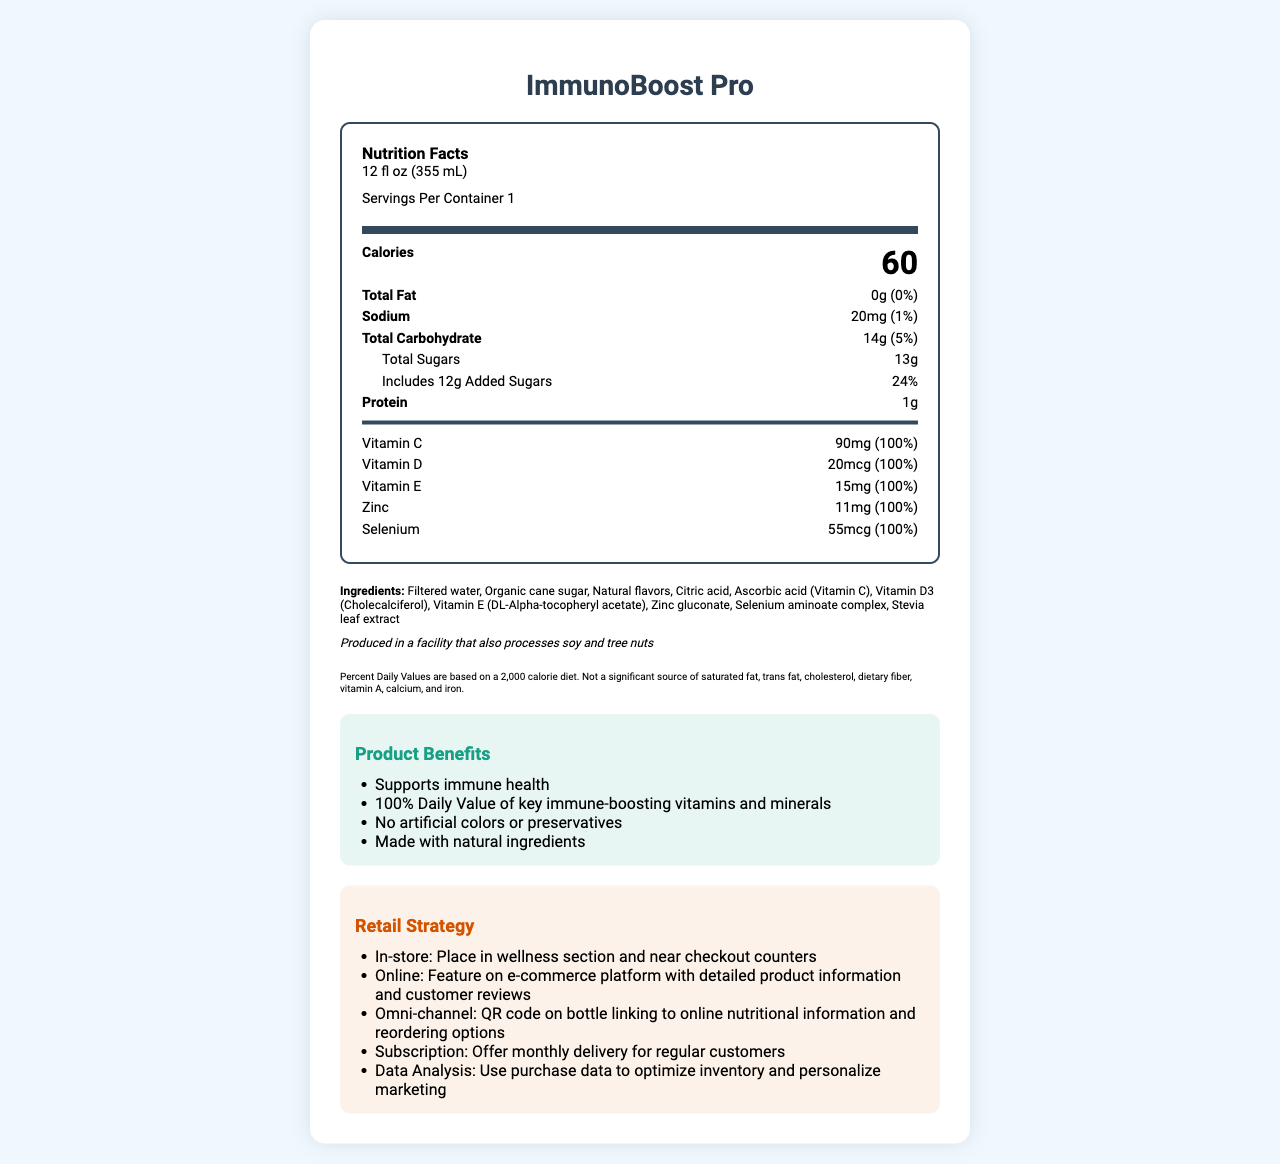what is the serving size for ImmunoBoost Pro? The serving size is directly stated under the "Nutrition Facts" section of the document.
Answer: 12 fl oz (355 mL) how many calories are there per serving? The calories per serving are listed prominently within the "Nutrition Facts" section.
Answer: 60 what amount of added sugars does ImmunoBoost Pro contain? The added sugars are specified under the "Total Sugars" section, whereby it states 12g of added sugars.
Answer: 12g which vitamins and minerals are 100% of the daily value (DV) in ImmunoBoost Pro? The daily value of 100% is given for Vitamin C (90mg), Vitamin D (20mcg), Vitamin E (15mg), Zinc (11mg), and Selenium (55mcg).
Answer: Vitamin C, Vitamin D, Vitamin E, Zinc, Selenium what are the main ingredients of ImmunoBoost Pro? The ingredients are listed under the "Ingredients" section of the document.
Answer: Filtered water, Organic cane sugar, Natural flavors, Citric acid, Ascorbic acid (Vitamin C), Vitamin D3 (Cholecalciferol), Vitamin E (DL-Alpha-tocopheryl acetate), Zinc gluconate, Selenium aminoate complex, Stevia leaf extract how much protein is in one serving of ImmunoBoost Pro? The protein content is listed at 1g per serving under the "Nutrition Facts".
Answer: 1g what is the sodium content per serving? The sodium content per serving is found under the "Nutrition Facts" and is listed as 20mg.
Answer: 20mg ImmunoBoost Pro is produced in a facility that processes which allergens? A. Dairy and peanuts B. Gluten and shellfish C. Soy and tree nuts D. Eggs and fish The allergen information specifies that the product is produced in a facility that processes soy and tree nuts.
Answer: C how is ImmunoBoost Pro marketed to support immune health? A. High protein content B. Low calorie C. 100% Daily Value of key immune-boosting vitamins and minerals D. Zero carbohydrates The marketing claims specify that the product has "100% Daily Value of key immune-boosting vitamins and minerals".
Answer: C is there any iron in ImmunoBoost Pro? The disclaimers mention that the product is "Not a significant source of iron", indicating negligible or no iron content.
Answer: No how would you summarize the nutrition information and benefits of ImmunoBoost Pro? The document provides detailed nutrition facts, highlighting the beverage's role in immune support with 100% DV of Vitamin C, Vitamin D, Vitamin E, Zinc, and Selenium. It also notes the product's pure ingredient list and various marketing claims.
Answer: ImmunoBoost Pro is a functional beverage that supports immune health by providing 100% daily value of several key vitamins and minerals, with 60 calories per serving. It contains low fat, a modest amount of carbohydrates, and no artificial colors or preservatives. what is the percentage daily value of total carbohydrates in ImmunoBoost Pro based on a 2,000 calorie diet? The percentage daily value of total carbohydrates is 5%, as stated in the "Nutrition Facts" section.
Answer: 5% does ImmunoBoost Pro contain any artificial colors or preservatives? The marketing claims highlight that the product contains "No artificial colors or preservatives".
Answer: No what are the proposed in-store and online strategies for selling ImmunoBoost Pro? The retail strategy section elaborates on the planned in-store and online strategies for effective sales.
Answer: In-store: Place in wellness section and near checkout counters. Online: Feature on e-commerce platform with detailed product information and customer reviews. how many servings are there per container of ImmunoBoost Pro? The servings per container are explicitly mentioned in the "Nutrition Facts" as 1.
Answer: 1 what is the price of ImmunoBoost Pro? The document does not provide any information on the price of ImmunoBoost Pro.
Answer: Cannot be determined how is the subscription model for ImmunoBoost Pro designed? The retail strategy section describes that the subscription model offers monthly delivery for regular customers.
Answer: Offer monthly delivery for regular customers 